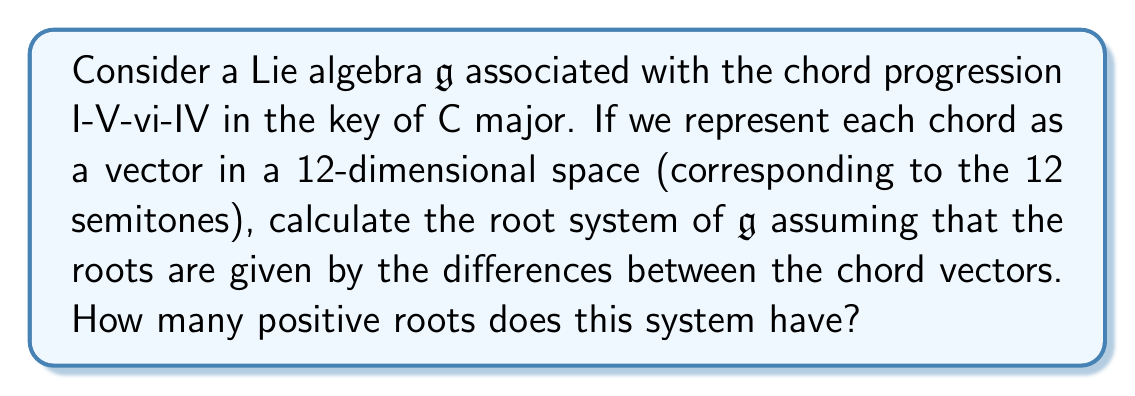Provide a solution to this math problem. Let's approach this step-by-step:

1) First, we need to represent each chord as a vector in a 12-dimensional space. In the key of C major:
   I (C): $(1,0,0,0,1,0,0,1,0,0,0,0)$
   V (G): $(0,0,0,0,0,0,1,0,0,1,0,0)$
   vi (Am): $(1,0,0,1,0,0,0,1,0,0,0,0)$
   IV (F): $(0,0,0,0,1,0,0,0,0,0,1,0)$

2) The roots of the Lie algebra are given by the differences between these vectors. We need to calculate:
   $\alpha_1 = V - I$
   $\alpha_2 = vi - V$
   $\alpha_3 = IV - vi$
   $\alpha_4 = I - IV$

3) Calculating these differences:
   $\alpha_1 = (-1,0,0,0,-1,0,1,-1,0,1,0,0)$
   $\alpha_2 = (1,0,0,1,0,0,-1,1,0,-1,0,0)$
   $\alpha_3 = (-1,0,0,-1,1,0,0,-1,0,0,1,0)$
   $\alpha_4 = (1,0,0,0,0,0,0,1,0,0,-1,0)$

4) These four vectors form the simple roots of our root system.

5) To find all positive roots, we need to consider all possible positive linear combinations of these simple roots. In this case:
   $\alpha_1$
   $\alpha_2$
   $\alpha_3$
   $\alpha_4$
   $\alpha_1 + \alpha_2$
   $\alpha_2 + \alpha_3$
   $\alpha_3 + \alpha_4$
   $\alpha_1 + \alpha_2 + \alpha_3$
   $\alpha_2 + \alpha_3 + \alpha_4$
   $\alpha_1 + \alpha_2 + \alpha_3 + \alpha_4$

6) Therefore, we have 10 positive roots in total.
Answer: The root system of the Lie algebra $\mathfrak{g}$ associated with the I-V-vi-IV chord progression has 10 positive roots. 